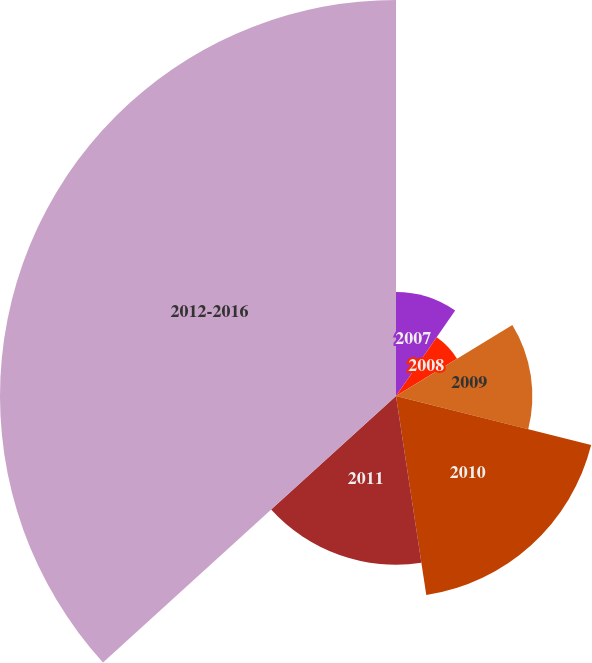Convert chart to OTSL. <chart><loc_0><loc_0><loc_500><loc_500><pie_chart><fcel>2007<fcel>2008<fcel>2009<fcel>2010<fcel>2011<fcel>2012-2016<nl><fcel>9.64%<fcel>6.63%<fcel>12.65%<fcel>18.67%<fcel>15.66%<fcel>36.74%<nl></chart> 